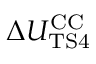Convert formula to latex. <formula><loc_0><loc_0><loc_500><loc_500>\Delta { U _ { T S 4 } ^ { C C } }</formula> 